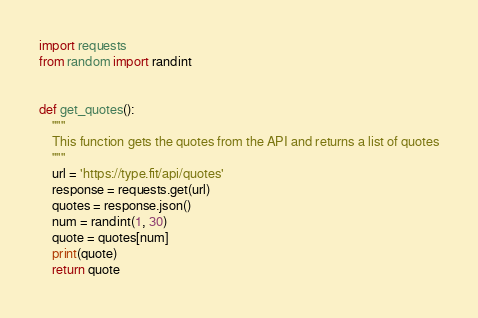Convert code to text. <code><loc_0><loc_0><loc_500><loc_500><_Python_>import requests
from random import randint


def get_quotes():
    """
    This function gets the quotes from the API and returns a list of quotes
    """
    url = 'https://type.fit/api/quotes'
    response = requests.get(url)
    quotes = response.json()
    num = randint(1, 30)
    quote = quotes[num]
    print(quote)
    return quote
</code> 